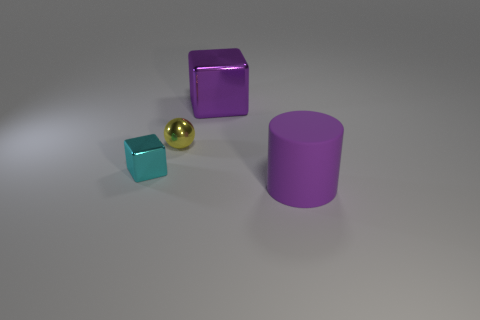Is there any other thing that is the same material as the big cylinder?
Ensure brevity in your answer.  No. Are the small yellow thing and the small block made of the same material?
Offer a very short reply. Yes. Are there more big blocks to the right of the ball than yellow matte cylinders?
Ensure brevity in your answer.  Yes. How many objects are cyan shiny things or purple objects that are behind the large cylinder?
Your answer should be compact. 2. Are there more large purple matte cylinders in front of the yellow metallic sphere than tiny yellow metal balls in front of the cylinder?
Provide a succinct answer. Yes. The large purple object that is to the right of the purple thing that is behind the big purple thing that is in front of the tiny ball is made of what material?
Keep it short and to the point. Rubber. There is a large thing that is made of the same material as the cyan cube; what is its shape?
Make the answer very short. Cube. There is a purple shiny cube that is behind the purple cylinder; is there a tiny shiny sphere that is behind it?
Keep it short and to the point. No. The purple shiny object has what size?
Make the answer very short. Large. How many objects are tiny yellow shiny blocks or blocks?
Your answer should be very brief. 2. 